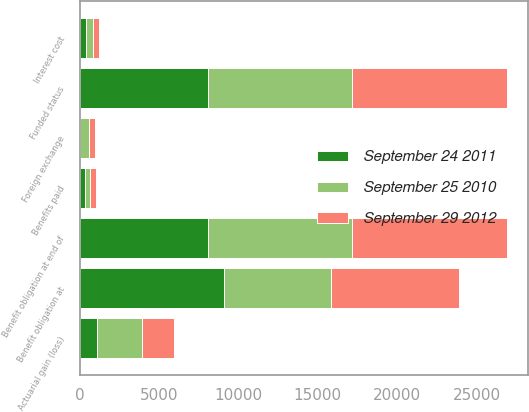<chart> <loc_0><loc_0><loc_500><loc_500><stacked_bar_chart><ecel><fcel>Benefit obligation at<fcel>Interest cost<fcel>Actuarial gain (loss)<fcel>Foreign exchange<fcel>Benefits paid<fcel>Benefit obligation at end of<fcel>Funded status<nl><fcel>September 29 2012<fcel>8064<fcel>391<fcel>2002<fcel>383<fcel>330<fcel>9744<fcel>9744<nl><fcel>September 24 2011<fcel>9093<fcel>389<fcel>1092<fcel>5<fcel>331<fcel>8064<fcel>8064<nl><fcel>September 25 2010<fcel>6736<fcel>401<fcel>2814<fcel>541<fcel>317<fcel>9093<fcel>9093<nl></chart> 